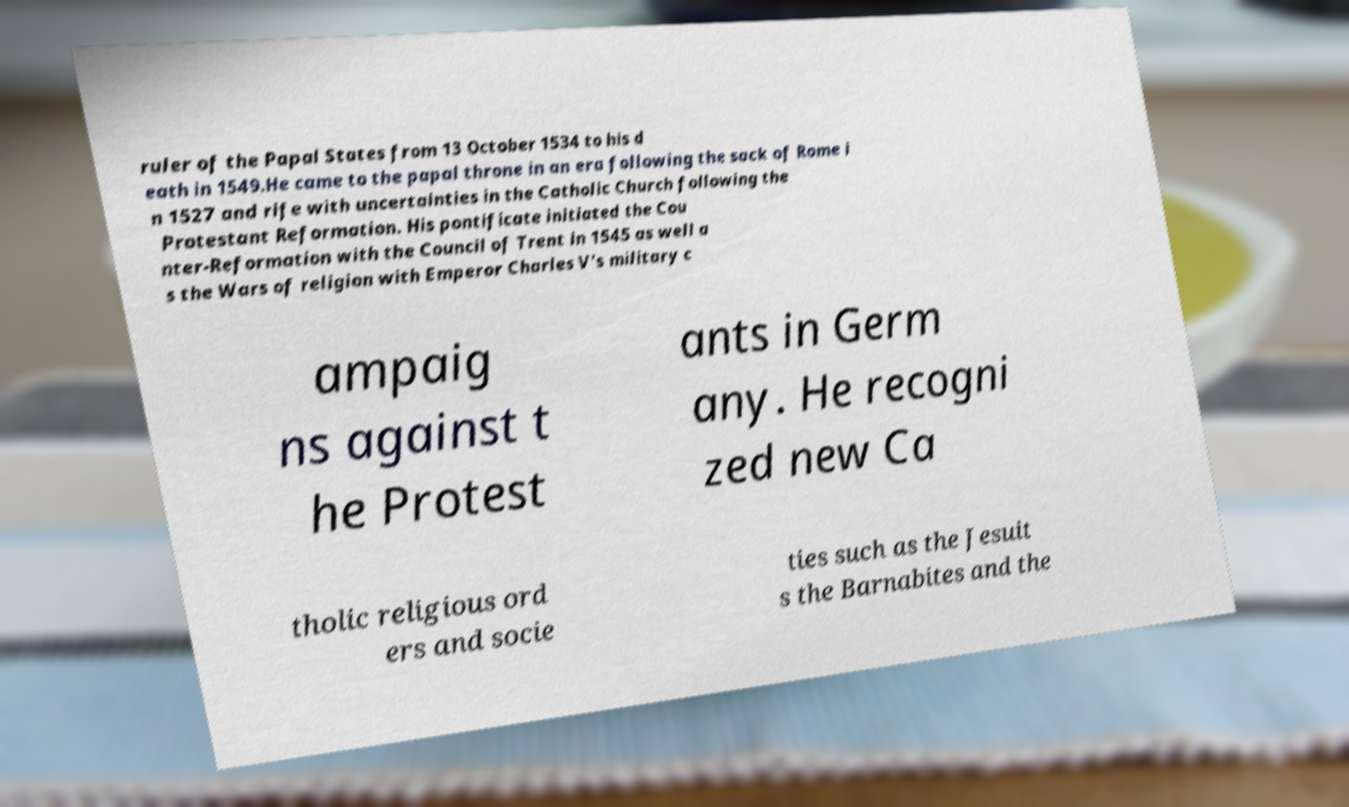Can you accurately transcribe the text from the provided image for me? ruler of the Papal States from 13 October 1534 to his d eath in 1549.He came to the papal throne in an era following the sack of Rome i n 1527 and rife with uncertainties in the Catholic Church following the Protestant Reformation. His pontificate initiated the Cou nter-Reformation with the Council of Trent in 1545 as well a s the Wars of religion with Emperor Charles V's military c ampaig ns against t he Protest ants in Germ any. He recogni zed new Ca tholic religious ord ers and socie ties such as the Jesuit s the Barnabites and the 